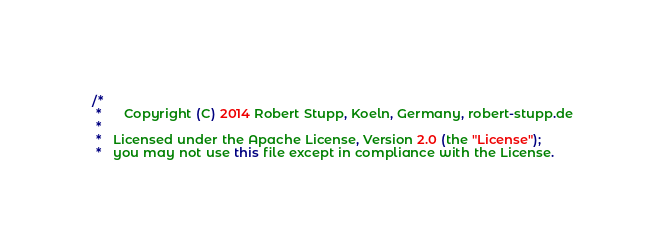Convert code to text. <code><loc_0><loc_0><loc_500><loc_500><_Java_>/*
 *      Copyright (C) 2014 Robert Stupp, Koeln, Germany, robert-stupp.de
 *
 *   Licensed under the Apache License, Version 2.0 (the "License");
 *   you may not use this file except in compliance with the License.</code> 